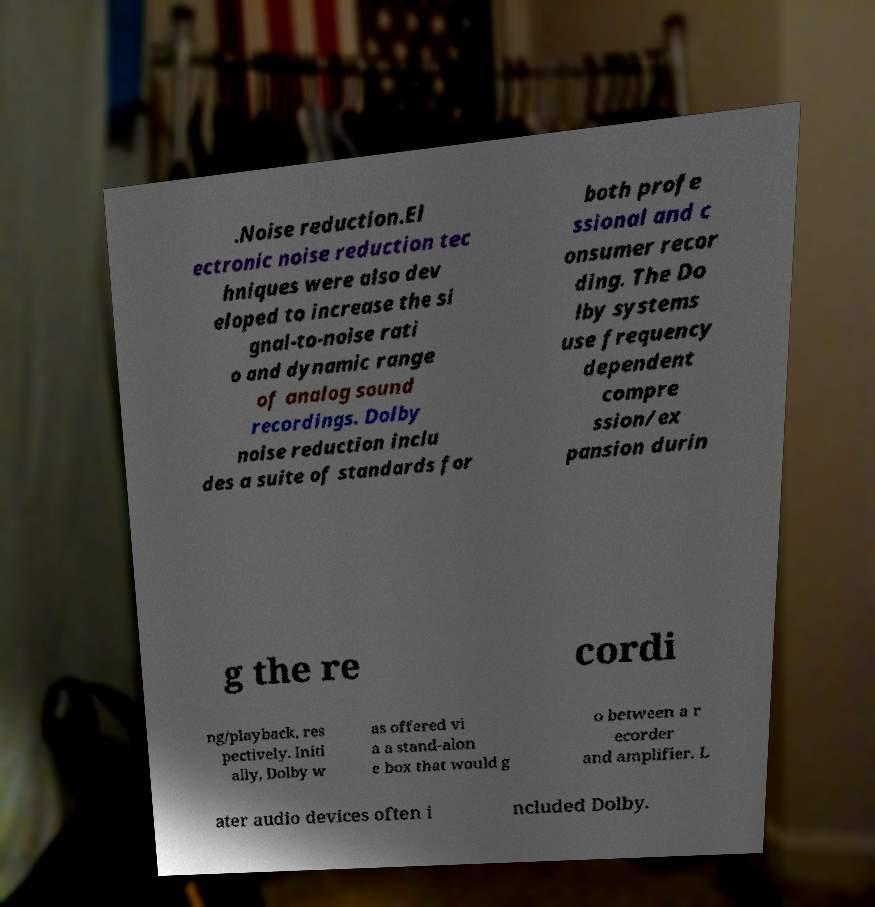There's text embedded in this image that I need extracted. Can you transcribe it verbatim? .Noise reduction.El ectronic noise reduction tec hniques were also dev eloped to increase the si gnal-to-noise rati o and dynamic range of analog sound recordings. Dolby noise reduction inclu des a suite of standards for both profe ssional and c onsumer recor ding. The Do lby systems use frequency dependent compre ssion/ex pansion durin g the re cordi ng/playback, res pectively. Initi ally, Dolby w as offered vi a a stand-alon e box that would g o between a r ecorder and amplifier. L ater audio devices often i ncluded Dolby. 